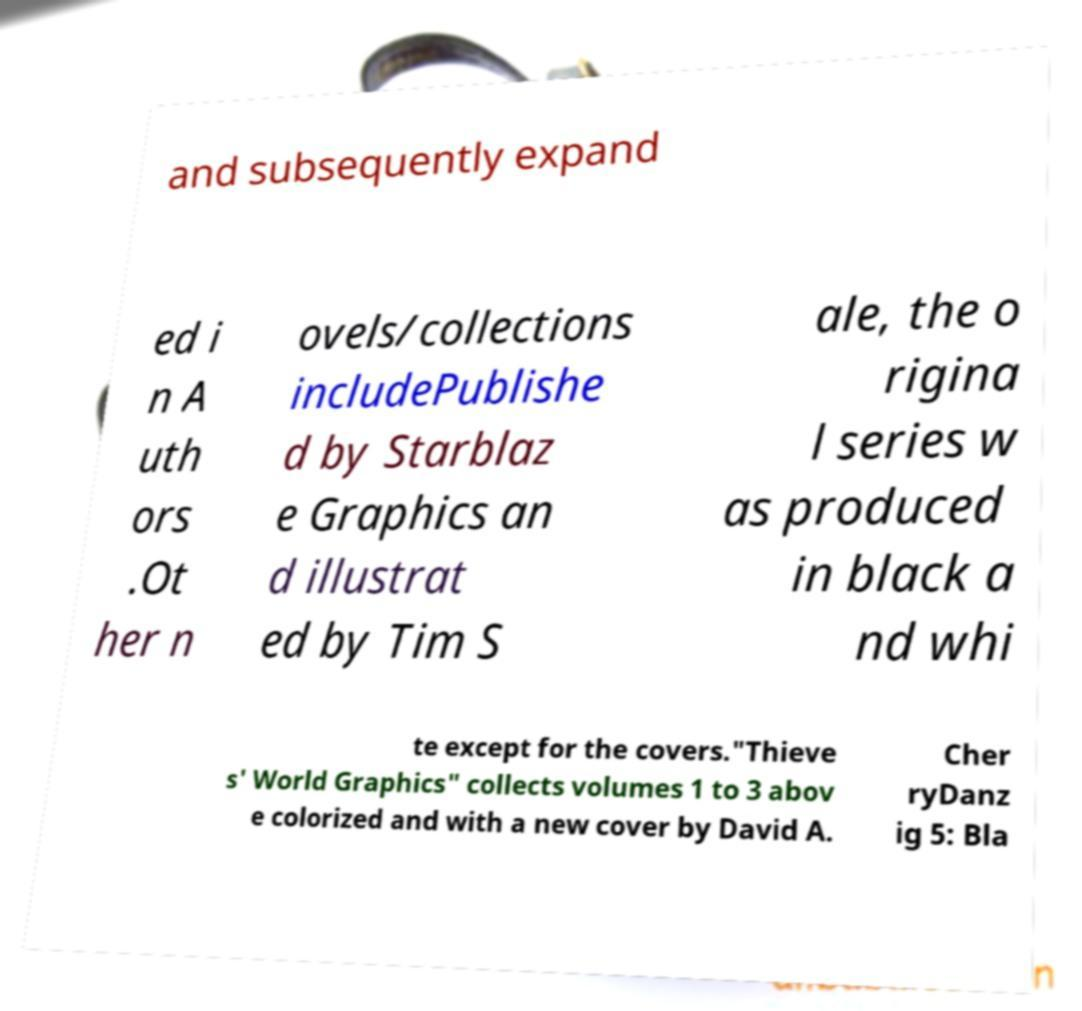There's text embedded in this image that I need extracted. Can you transcribe it verbatim? and subsequently expand ed i n A uth ors .Ot her n ovels/collections includePublishe d by Starblaz e Graphics an d illustrat ed by Tim S ale, the o rigina l series w as produced in black a nd whi te except for the covers."Thieve s' World Graphics" collects volumes 1 to 3 abov e colorized and with a new cover by David A. Cher ryDanz ig 5: Bla 